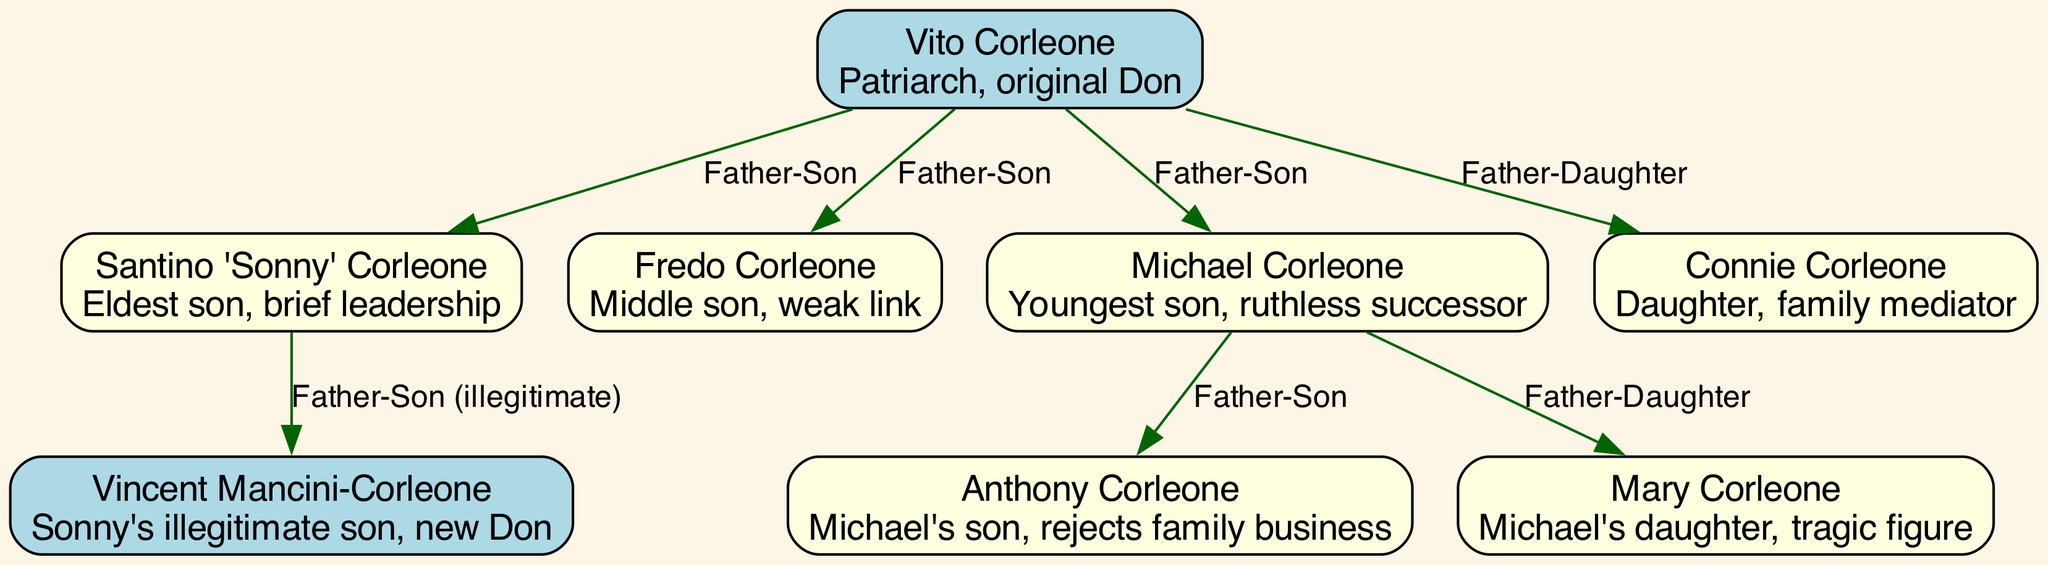What is the name of the patriarch of the Corleone family? The diagram identifies Vito Corleone as the patriarch, or original Don, of the family, which is explicitly stated in his description.
Answer: Vito Corleone How many sons does Vito Corleone have? By examining the connections in the diagram, Vito Corleone is shown to have three sons: Sonny, Fredo, and Michael, indicated by the three edges labeled "Father-Son" leading from Vito.
Answer: 3 Who is identified as the youngest son of Vito Corleone? The diagram shows that Michael Corleone is labeled as the youngest son in his description, thus clearly identifying him as Vito's youngest child.
Answer: Michael Corleone What type of relationship exists between Sonny Corleone and Vincent Mancini-Corleone? The diagram indicates a "Father-Son (illegitimate)" relationship between Sonny Corleone and Vincent Mancini-Corleone, as labeled on the connecting edge between these two nodes.
Answer: Father-Son (illegitimate) Which family member does Anthony Corleone reject? By analyzing the diagram, it is noted in Anthony's description that he rejects the family business, indicating a disconnection from the Corleone criminal empire.
Answer: Family business What role does Connie Corleone play within the family dynamics? In her description, Connie Corleone is labeled as the family mediator, which indicates her role as a bridge between conflicts within the family rather than as a direct participant in power struggles.
Answer: Family mediator Who is the tragic figure among Michael Corleone's children? The diagram explicitly describes Mary Corleone as a tragic figure in her description, distinguishing her from the other children of Michael.
Answer: Mary Corleone Which Corleone family member succeeds Michael as the new Don? The diagram indicates that Vincent Mancini-Corleone is the new Don, which is emphasized in his description and his position in the family tree as Sonny's illegitimate son.
Answer: Vincent Mancini-Corleone How many daughters does Vito Corleone have? The diagram indicates that Vito Corleone has one daughter, Connie Corleone, as shown by the edge labeled "Father-Daughter" connecting Vito to Connie.
Answer: 1 